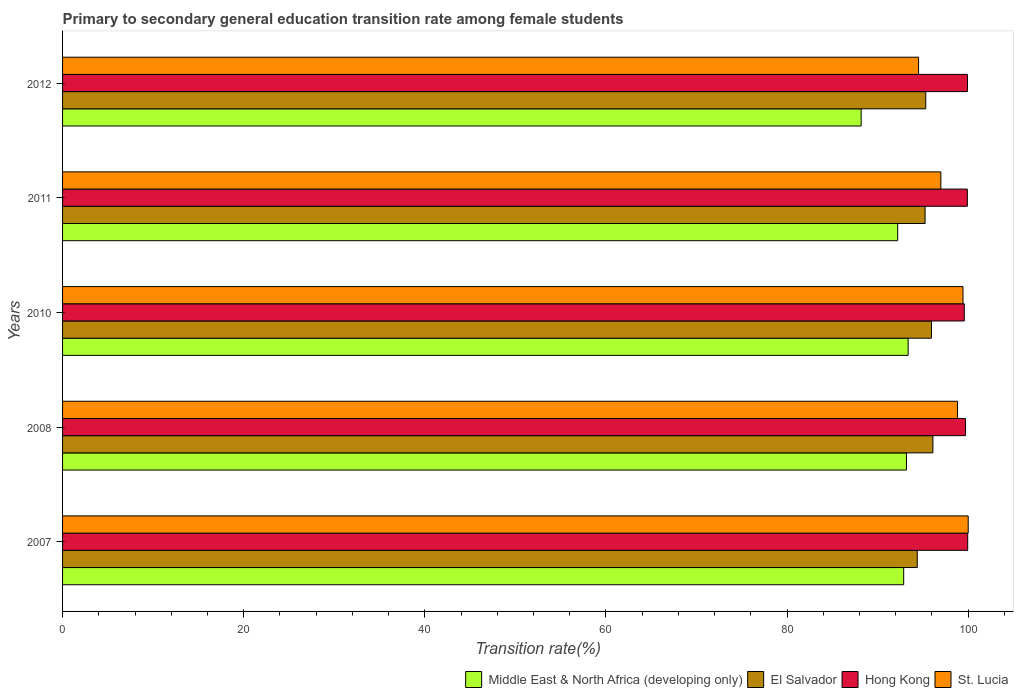How many groups of bars are there?
Your answer should be compact. 5. How many bars are there on the 4th tick from the bottom?
Offer a terse response. 4. What is the transition rate in St. Lucia in 2011?
Ensure brevity in your answer.  96.98. Across all years, what is the maximum transition rate in Hong Kong?
Provide a short and direct response. 99.94. Across all years, what is the minimum transition rate in St. Lucia?
Your answer should be compact. 94.52. What is the total transition rate in Hong Kong in the graph?
Provide a short and direct response. 499.03. What is the difference between the transition rate in St. Lucia in 2008 and that in 2010?
Your answer should be very brief. -0.6. What is the difference between the transition rate in Hong Kong in 2010 and the transition rate in Middle East & North Africa (developing only) in 2011?
Ensure brevity in your answer.  7.35. What is the average transition rate in Middle East & North Africa (developing only) per year?
Provide a short and direct response. 91.96. In the year 2012, what is the difference between the transition rate in St. Lucia and transition rate in El Salvador?
Give a very brief answer. -0.79. What is the ratio of the transition rate in Hong Kong in 2008 to that in 2012?
Your answer should be very brief. 1. Is the transition rate in Middle East & North Africa (developing only) in 2008 less than that in 2010?
Offer a very short reply. Yes. Is the difference between the transition rate in St. Lucia in 2007 and 2008 greater than the difference between the transition rate in El Salvador in 2007 and 2008?
Your response must be concise. Yes. What is the difference between the highest and the second highest transition rate in Hong Kong?
Provide a succinct answer. 0.03. What is the difference between the highest and the lowest transition rate in Middle East & North Africa (developing only)?
Offer a very short reply. 5.19. In how many years, is the transition rate in El Salvador greater than the average transition rate in El Salvador taken over all years?
Make the answer very short. 2. Is the sum of the transition rate in Middle East & North Africa (developing only) in 2010 and 2012 greater than the maximum transition rate in El Salvador across all years?
Offer a terse response. Yes. Is it the case that in every year, the sum of the transition rate in El Salvador and transition rate in St. Lucia is greater than the sum of transition rate in Middle East & North Africa (developing only) and transition rate in Hong Kong?
Your answer should be compact. No. What does the 3rd bar from the top in 2012 represents?
Offer a terse response. El Salvador. What does the 2nd bar from the bottom in 2011 represents?
Provide a short and direct response. El Salvador. Are all the bars in the graph horizontal?
Your answer should be compact. Yes. What is the difference between two consecutive major ticks on the X-axis?
Your answer should be compact. 20. Are the values on the major ticks of X-axis written in scientific E-notation?
Provide a succinct answer. No. Does the graph contain any zero values?
Offer a terse response. No. How many legend labels are there?
Make the answer very short. 4. How are the legend labels stacked?
Your answer should be compact. Horizontal. What is the title of the graph?
Your response must be concise. Primary to secondary general education transition rate among female students. Does "Nepal" appear as one of the legend labels in the graph?
Your answer should be compact. No. What is the label or title of the X-axis?
Your answer should be very brief. Transition rate(%). What is the Transition rate(%) of Middle East & North Africa (developing only) in 2007?
Provide a succinct answer. 92.88. What is the Transition rate(%) of El Salvador in 2007?
Make the answer very short. 94.37. What is the Transition rate(%) of Hong Kong in 2007?
Offer a terse response. 99.94. What is the Transition rate(%) of St. Lucia in 2007?
Keep it short and to the point. 100. What is the Transition rate(%) of Middle East & North Africa (developing only) in 2008?
Give a very brief answer. 93.18. What is the Transition rate(%) of El Salvador in 2008?
Your answer should be very brief. 96.1. What is the Transition rate(%) in Hong Kong in 2008?
Your answer should be very brief. 99.7. What is the Transition rate(%) in St. Lucia in 2008?
Ensure brevity in your answer.  98.82. What is the Transition rate(%) in Middle East & North Africa (developing only) in 2010?
Provide a short and direct response. 93.37. What is the Transition rate(%) in El Salvador in 2010?
Offer a very short reply. 95.94. What is the Transition rate(%) in Hong Kong in 2010?
Keep it short and to the point. 99.57. What is the Transition rate(%) of St. Lucia in 2010?
Ensure brevity in your answer.  99.42. What is the Transition rate(%) in Middle East & North Africa (developing only) in 2011?
Provide a short and direct response. 92.22. What is the Transition rate(%) of El Salvador in 2011?
Give a very brief answer. 95.24. What is the Transition rate(%) of Hong Kong in 2011?
Keep it short and to the point. 99.9. What is the Transition rate(%) in St. Lucia in 2011?
Your answer should be compact. 96.98. What is the Transition rate(%) in Middle East & North Africa (developing only) in 2012?
Ensure brevity in your answer.  88.18. What is the Transition rate(%) in El Salvador in 2012?
Provide a succinct answer. 95.31. What is the Transition rate(%) in Hong Kong in 2012?
Your response must be concise. 99.92. What is the Transition rate(%) of St. Lucia in 2012?
Your answer should be very brief. 94.52. Across all years, what is the maximum Transition rate(%) of Middle East & North Africa (developing only)?
Offer a very short reply. 93.37. Across all years, what is the maximum Transition rate(%) in El Salvador?
Provide a short and direct response. 96.1. Across all years, what is the maximum Transition rate(%) of Hong Kong?
Your answer should be very brief. 99.94. Across all years, what is the maximum Transition rate(%) of St. Lucia?
Provide a succinct answer. 100. Across all years, what is the minimum Transition rate(%) of Middle East & North Africa (developing only)?
Provide a short and direct response. 88.18. Across all years, what is the minimum Transition rate(%) in El Salvador?
Give a very brief answer. 94.37. Across all years, what is the minimum Transition rate(%) in Hong Kong?
Your response must be concise. 99.57. Across all years, what is the minimum Transition rate(%) in St. Lucia?
Offer a terse response. 94.52. What is the total Transition rate(%) of Middle East & North Africa (developing only) in the graph?
Your response must be concise. 459.82. What is the total Transition rate(%) in El Salvador in the graph?
Offer a terse response. 476.97. What is the total Transition rate(%) in Hong Kong in the graph?
Provide a short and direct response. 499.03. What is the total Transition rate(%) of St. Lucia in the graph?
Your answer should be very brief. 489.75. What is the difference between the Transition rate(%) in Middle East & North Africa (developing only) in 2007 and that in 2008?
Your response must be concise. -0.31. What is the difference between the Transition rate(%) of El Salvador in 2007 and that in 2008?
Offer a very short reply. -1.73. What is the difference between the Transition rate(%) in Hong Kong in 2007 and that in 2008?
Ensure brevity in your answer.  0.24. What is the difference between the Transition rate(%) of St. Lucia in 2007 and that in 2008?
Keep it short and to the point. 1.18. What is the difference between the Transition rate(%) of Middle East & North Africa (developing only) in 2007 and that in 2010?
Provide a short and direct response. -0.49. What is the difference between the Transition rate(%) of El Salvador in 2007 and that in 2010?
Offer a very short reply. -1.57. What is the difference between the Transition rate(%) in Hong Kong in 2007 and that in 2010?
Your answer should be compact. 0.38. What is the difference between the Transition rate(%) of St. Lucia in 2007 and that in 2010?
Offer a terse response. 0.58. What is the difference between the Transition rate(%) of Middle East & North Africa (developing only) in 2007 and that in 2011?
Offer a very short reply. 0.66. What is the difference between the Transition rate(%) of El Salvador in 2007 and that in 2011?
Your answer should be very brief. -0.87. What is the difference between the Transition rate(%) in Hong Kong in 2007 and that in 2011?
Provide a succinct answer. 0.04. What is the difference between the Transition rate(%) in St. Lucia in 2007 and that in 2011?
Provide a succinct answer. 3.02. What is the difference between the Transition rate(%) in Middle East & North Africa (developing only) in 2007 and that in 2012?
Make the answer very short. 4.7. What is the difference between the Transition rate(%) in El Salvador in 2007 and that in 2012?
Your answer should be compact. -0.94. What is the difference between the Transition rate(%) in Hong Kong in 2007 and that in 2012?
Provide a short and direct response. 0.03. What is the difference between the Transition rate(%) of St. Lucia in 2007 and that in 2012?
Ensure brevity in your answer.  5.48. What is the difference between the Transition rate(%) in Middle East & North Africa (developing only) in 2008 and that in 2010?
Give a very brief answer. -0.18. What is the difference between the Transition rate(%) in El Salvador in 2008 and that in 2010?
Make the answer very short. 0.16. What is the difference between the Transition rate(%) in Hong Kong in 2008 and that in 2010?
Your answer should be compact. 0.14. What is the difference between the Transition rate(%) in St. Lucia in 2008 and that in 2010?
Your answer should be very brief. -0.6. What is the difference between the Transition rate(%) of Middle East & North Africa (developing only) in 2008 and that in 2011?
Offer a very short reply. 0.96. What is the difference between the Transition rate(%) in El Salvador in 2008 and that in 2011?
Make the answer very short. 0.86. What is the difference between the Transition rate(%) of Hong Kong in 2008 and that in 2011?
Offer a very short reply. -0.2. What is the difference between the Transition rate(%) in St. Lucia in 2008 and that in 2011?
Give a very brief answer. 1.84. What is the difference between the Transition rate(%) of Middle East & North Africa (developing only) in 2008 and that in 2012?
Give a very brief answer. 5. What is the difference between the Transition rate(%) of El Salvador in 2008 and that in 2012?
Provide a succinct answer. 0.79. What is the difference between the Transition rate(%) of Hong Kong in 2008 and that in 2012?
Make the answer very short. -0.22. What is the difference between the Transition rate(%) of St. Lucia in 2008 and that in 2012?
Give a very brief answer. 4.3. What is the difference between the Transition rate(%) of Middle East & North Africa (developing only) in 2010 and that in 2011?
Your answer should be compact. 1.15. What is the difference between the Transition rate(%) of El Salvador in 2010 and that in 2011?
Make the answer very short. 0.71. What is the difference between the Transition rate(%) in Hong Kong in 2010 and that in 2011?
Offer a terse response. -0.34. What is the difference between the Transition rate(%) of St. Lucia in 2010 and that in 2011?
Offer a terse response. 2.44. What is the difference between the Transition rate(%) of Middle East & North Africa (developing only) in 2010 and that in 2012?
Make the answer very short. 5.19. What is the difference between the Transition rate(%) in El Salvador in 2010 and that in 2012?
Offer a very short reply. 0.63. What is the difference between the Transition rate(%) in Hong Kong in 2010 and that in 2012?
Give a very brief answer. -0.35. What is the difference between the Transition rate(%) in St. Lucia in 2010 and that in 2012?
Provide a short and direct response. 4.91. What is the difference between the Transition rate(%) in Middle East & North Africa (developing only) in 2011 and that in 2012?
Offer a very short reply. 4.04. What is the difference between the Transition rate(%) of El Salvador in 2011 and that in 2012?
Keep it short and to the point. -0.07. What is the difference between the Transition rate(%) of Hong Kong in 2011 and that in 2012?
Give a very brief answer. -0.01. What is the difference between the Transition rate(%) in St. Lucia in 2011 and that in 2012?
Provide a short and direct response. 2.46. What is the difference between the Transition rate(%) of Middle East & North Africa (developing only) in 2007 and the Transition rate(%) of El Salvador in 2008?
Ensure brevity in your answer.  -3.23. What is the difference between the Transition rate(%) of Middle East & North Africa (developing only) in 2007 and the Transition rate(%) of Hong Kong in 2008?
Your answer should be very brief. -6.83. What is the difference between the Transition rate(%) in Middle East & North Africa (developing only) in 2007 and the Transition rate(%) in St. Lucia in 2008?
Keep it short and to the point. -5.95. What is the difference between the Transition rate(%) in El Salvador in 2007 and the Transition rate(%) in Hong Kong in 2008?
Ensure brevity in your answer.  -5.33. What is the difference between the Transition rate(%) in El Salvador in 2007 and the Transition rate(%) in St. Lucia in 2008?
Make the answer very short. -4.45. What is the difference between the Transition rate(%) of Hong Kong in 2007 and the Transition rate(%) of St. Lucia in 2008?
Your answer should be compact. 1.12. What is the difference between the Transition rate(%) of Middle East & North Africa (developing only) in 2007 and the Transition rate(%) of El Salvador in 2010?
Offer a very short reply. -3.07. What is the difference between the Transition rate(%) of Middle East & North Africa (developing only) in 2007 and the Transition rate(%) of Hong Kong in 2010?
Provide a short and direct response. -6.69. What is the difference between the Transition rate(%) of Middle East & North Africa (developing only) in 2007 and the Transition rate(%) of St. Lucia in 2010?
Offer a very short reply. -6.55. What is the difference between the Transition rate(%) in El Salvador in 2007 and the Transition rate(%) in Hong Kong in 2010?
Make the answer very short. -5.19. What is the difference between the Transition rate(%) of El Salvador in 2007 and the Transition rate(%) of St. Lucia in 2010?
Offer a very short reply. -5.05. What is the difference between the Transition rate(%) of Hong Kong in 2007 and the Transition rate(%) of St. Lucia in 2010?
Provide a succinct answer. 0.52. What is the difference between the Transition rate(%) in Middle East & North Africa (developing only) in 2007 and the Transition rate(%) in El Salvador in 2011?
Offer a very short reply. -2.36. What is the difference between the Transition rate(%) of Middle East & North Africa (developing only) in 2007 and the Transition rate(%) of Hong Kong in 2011?
Offer a very short reply. -7.03. What is the difference between the Transition rate(%) in Middle East & North Africa (developing only) in 2007 and the Transition rate(%) in St. Lucia in 2011?
Keep it short and to the point. -4.11. What is the difference between the Transition rate(%) in El Salvador in 2007 and the Transition rate(%) in Hong Kong in 2011?
Offer a very short reply. -5.53. What is the difference between the Transition rate(%) in El Salvador in 2007 and the Transition rate(%) in St. Lucia in 2011?
Make the answer very short. -2.61. What is the difference between the Transition rate(%) of Hong Kong in 2007 and the Transition rate(%) of St. Lucia in 2011?
Ensure brevity in your answer.  2.96. What is the difference between the Transition rate(%) of Middle East & North Africa (developing only) in 2007 and the Transition rate(%) of El Salvador in 2012?
Offer a terse response. -2.43. What is the difference between the Transition rate(%) of Middle East & North Africa (developing only) in 2007 and the Transition rate(%) of Hong Kong in 2012?
Provide a short and direct response. -7.04. What is the difference between the Transition rate(%) of Middle East & North Africa (developing only) in 2007 and the Transition rate(%) of St. Lucia in 2012?
Keep it short and to the point. -1.64. What is the difference between the Transition rate(%) in El Salvador in 2007 and the Transition rate(%) in Hong Kong in 2012?
Your answer should be compact. -5.55. What is the difference between the Transition rate(%) in El Salvador in 2007 and the Transition rate(%) in St. Lucia in 2012?
Give a very brief answer. -0.15. What is the difference between the Transition rate(%) of Hong Kong in 2007 and the Transition rate(%) of St. Lucia in 2012?
Your answer should be compact. 5.43. What is the difference between the Transition rate(%) in Middle East & North Africa (developing only) in 2008 and the Transition rate(%) in El Salvador in 2010?
Keep it short and to the point. -2.76. What is the difference between the Transition rate(%) of Middle East & North Africa (developing only) in 2008 and the Transition rate(%) of Hong Kong in 2010?
Your answer should be compact. -6.38. What is the difference between the Transition rate(%) in Middle East & North Africa (developing only) in 2008 and the Transition rate(%) in St. Lucia in 2010?
Make the answer very short. -6.24. What is the difference between the Transition rate(%) of El Salvador in 2008 and the Transition rate(%) of Hong Kong in 2010?
Make the answer very short. -3.46. What is the difference between the Transition rate(%) in El Salvador in 2008 and the Transition rate(%) in St. Lucia in 2010?
Keep it short and to the point. -3.32. What is the difference between the Transition rate(%) of Hong Kong in 2008 and the Transition rate(%) of St. Lucia in 2010?
Provide a succinct answer. 0.28. What is the difference between the Transition rate(%) in Middle East & North Africa (developing only) in 2008 and the Transition rate(%) in El Salvador in 2011?
Provide a succinct answer. -2.06. What is the difference between the Transition rate(%) in Middle East & North Africa (developing only) in 2008 and the Transition rate(%) in Hong Kong in 2011?
Provide a short and direct response. -6.72. What is the difference between the Transition rate(%) in Middle East & North Africa (developing only) in 2008 and the Transition rate(%) in St. Lucia in 2011?
Provide a succinct answer. -3.8. What is the difference between the Transition rate(%) of El Salvador in 2008 and the Transition rate(%) of Hong Kong in 2011?
Your response must be concise. -3.8. What is the difference between the Transition rate(%) of El Salvador in 2008 and the Transition rate(%) of St. Lucia in 2011?
Your answer should be very brief. -0.88. What is the difference between the Transition rate(%) in Hong Kong in 2008 and the Transition rate(%) in St. Lucia in 2011?
Make the answer very short. 2.72. What is the difference between the Transition rate(%) in Middle East & North Africa (developing only) in 2008 and the Transition rate(%) in El Salvador in 2012?
Your answer should be compact. -2.13. What is the difference between the Transition rate(%) in Middle East & North Africa (developing only) in 2008 and the Transition rate(%) in Hong Kong in 2012?
Provide a short and direct response. -6.74. What is the difference between the Transition rate(%) of Middle East & North Africa (developing only) in 2008 and the Transition rate(%) of St. Lucia in 2012?
Offer a very short reply. -1.34. What is the difference between the Transition rate(%) in El Salvador in 2008 and the Transition rate(%) in Hong Kong in 2012?
Provide a succinct answer. -3.82. What is the difference between the Transition rate(%) of El Salvador in 2008 and the Transition rate(%) of St. Lucia in 2012?
Provide a short and direct response. 1.58. What is the difference between the Transition rate(%) in Hong Kong in 2008 and the Transition rate(%) in St. Lucia in 2012?
Offer a terse response. 5.18. What is the difference between the Transition rate(%) in Middle East & North Africa (developing only) in 2010 and the Transition rate(%) in El Salvador in 2011?
Your answer should be compact. -1.87. What is the difference between the Transition rate(%) of Middle East & North Africa (developing only) in 2010 and the Transition rate(%) of Hong Kong in 2011?
Provide a short and direct response. -6.54. What is the difference between the Transition rate(%) in Middle East & North Africa (developing only) in 2010 and the Transition rate(%) in St. Lucia in 2011?
Offer a very short reply. -3.62. What is the difference between the Transition rate(%) in El Salvador in 2010 and the Transition rate(%) in Hong Kong in 2011?
Offer a terse response. -3.96. What is the difference between the Transition rate(%) of El Salvador in 2010 and the Transition rate(%) of St. Lucia in 2011?
Offer a very short reply. -1.04. What is the difference between the Transition rate(%) in Hong Kong in 2010 and the Transition rate(%) in St. Lucia in 2011?
Your answer should be compact. 2.58. What is the difference between the Transition rate(%) of Middle East & North Africa (developing only) in 2010 and the Transition rate(%) of El Salvador in 2012?
Your response must be concise. -1.94. What is the difference between the Transition rate(%) in Middle East & North Africa (developing only) in 2010 and the Transition rate(%) in Hong Kong in 2012?
Your response must be concise. -6.55. What is the difference between the Transition rate(%) of Middle East & North Africa (developing only) in 2010 and the Transition rate(%) of St. Lucia in 2012?
Your answer should be compact. -1.15. What is the difference between the Transition rate(%) in El Salvador in 2010 and the Transition rate(%) in Hong Kong in 2012?
Offer a very short reply. -3.97. What is the difference between the Transition rate(%) in El Salvador in 2010 and the Transition rate(%) in St. Lucia in 2012?
Give a very brief answer. 1.43. What is the difference between the Transition rate(%) in Hong Kong in 2010 and the Transition rate(%) in St. Lucia in 2012?
Make the answer very short. 5.05. What is the difference between the Transition rate(%) in Middle East & North Africa (developing only) in 2011 and the Transition rate(%) in El Salvador in 2012?
Ensure brevity in your answer.  -3.09. What is the difference between the Transition rate(%) in Middle East & North Africa (developing only) in 2011 and the Transition rate(%) in Hong Kong in 2012?
Ensure brevity in your answer.  -7.7. What is the difference between the Transition rate(%) of Middle East & North Africa (developing only) in 2011 and the Transition rate(%) of St. Lucia in 2012?
Offer a very short reply. -2.3. What is the difference between the Transition rate(%) in El Salvador in 2011 and the Transition rate(%) in Hong Kong in 2012?
Your response must be concise. -4.68. What is the difference between the Transition rate(%) in El Salvador in 2011 and the Transition rate(%) in St. Lucia in 2012?
Your answer should be very brief. 0.72. What is the difference between the Transition rate(%) in Hong Kong in 2011 and the Transition rate(%) in St. Lucia in 2012?
Your answer should be very brief. 5.39. What is the average Transition rate(%) of Middle East & North Africa (developing only) per year?
Keep it short and to the point. 91.96. What is the average Transition rate(%) in El Salvador per year?
Your answer should be very brief. 95.39. What is the average Transition rate(%) of Hong Kong per year?
Your answer should be very brief. 99.81. What is the average Transition rate(%) in St. Lucia per year?
Keep it short and to the point. 97.95. In the year 2007, what is the difference between the Transition rate(%) in Middle East & North Africa (developing only) and Transition rate(%) in El Salvador?
Give a very brief answer. -1.5. In the year 2007, what is the difference between the Transition rate(%) of Middle East & North Africa (developing only) and Transition rate(%) of Hong Kong?
Give a very brief answer. -7.07. In the year 2007, what is the difference between the Transition rate(%) in Middle East & North Africa (developing only) and Transition rate(%) in St. Lucia?
Your answer should be compact. -7.12. In the year 2007, what is the difference between the Transition rate(%) of El Salvador and Transition rate(%) of Hong Kong?
Provide a succinct answer. -5.57. In the year 2007, what is the difference between the Transition rate(%) in El Salvador and Transition rate(%) in St. Lucia?
Offer a terse response. -5.63. In the year 2007, what is the difference between the Transition rate(%) in Hong Kong and Transition rate(%) in St. Lucia?
Offer a terse response. -0.06. In the year 2008, what is the difference between the Transition rate(%) in Middle East & North Africa (developing only) and Transition rate(%) in El Salvador?
Your answer should be very brief. -2.92. In the year 2008, what is the difference between the Transition rate(%) of Middle East & North Africa (developing only) and Transition rate(%) of Hong Kong?
Provide a short and direct response. -6.52. In the year 2008, what is the difference between the Transition rate(%) in Middle East & North Africa (developing only) and Transition rate(%) in St. Lucia?
Your response must be concise. -5.64. In the year 2008, what is the difference between the Transition rate(%) of El Salvador and Transition rate(%) of Hong Kong?
Provide a short and direct response. -3.6. In the year 2008, what is the difference between the Transition rate(%) of El Salvador and Transition rate(%) of St. Lucia?
Your answer should be very brief. -2.72. In the year 2008, what is the difference between the Transition rate(%) of Hong Kong and Transition rate(%) of St. Lucia?
Offer a very short reply. 0.88. In the year 2010, what is the difference between the Transition rate(%) of Middle East & North Africa (developing only) and Transition rate(%) of El Salvador?
Your answer should be very brief. -2.58. In the year 2010, what is the difference between the Transition rate(%) in Middle East & North Africa (developing only) and Transition rate(%) in Hong Kong?
Your answer should be very brief. -6.2. In the year 2010, what is the difference between the Transition rate(%) of Middle East & North Africa (developing only) and Transition rate(%) of St. Lucia?
Ensure brevity in your answer.  -6.06. In the year 2010, what is the difference between the Transition rate(%) of El Salvador and Transition rate(%) of Hong Kong?
Your answer should be very brief. -3.62. In the year 2010, what is the difference between the Transition rate(%) of El Salvador and Transition rate(%) of St. Lucia?
Your answer should be compact. -3.48. In the year 2010, what is the difference between the Transition rate(%) in Hong Kong and Transition rate(%) in St. Lucia?
Provide a succinct answer. 0.14. In the year 2011, what is the difference between the Transition rate(%) of Middle East & North Africa (developing only) and Transition rate(%) of El Salvador?
Your response must be concise. -3.02. In the year 2011, what is the difference between the Transition rate(%) of Middle East & North Africa (developing only) and Transition rate(%) of Hong Kong?
Your answer should be compact. -7.69. In the year 2011, what is the difference between the Transition rate(%) in Middle East & North Africa (developing only) and Transition rate(%) in St. Lucia?
Keep it short and to the point. -4.77. In the year 2011, what is the difference between the Transition rate(%) in El Salvador and Transition rate(%) in Hong Kong?
Provide a short and direct response. -4.67. In the year 2011, what is the difference between the Transition rate(%) of El Salvador and Transition rate(%) of St. Lucia?
Your answer should be compact. -1.74. In the year 2011, what is the difference between the Transition rate(%) of Hong Kong and Transition rate(%) of St. Lucia?
Offer a very short reply. 2.92. In the year 2012, what is the difference between the Transition rate(%) of Middle East & North Africa (developing only) and Transition rate(%) of El Salvador?
Your answer should be compact. -7.13. In the year 2012, what is the difference between the Transition rate(%) in Middle East & North Africa (developing only) and Transition rate(%) in Hong Kong?
Your answer should be very brief. -11.74. In the year 2012, what is the difference between the Transition rate(%) of Middle East & North Africa (developing only) and Transition rate(%) of St. Lucia?
Your response must be concise. -6.34. In the year 2012, what is the difference between the Transition rate(%) in El Salvador and Transition rate(%) in Hong Kong?
Offer a very short reply. -4.61. In the year 2012, what is the difference between the Transition rate(%) of El Salvador and Transition rate(%) of St. Lucia?
Your answer should be compact. 0.79. In the year 2012, what is the difference between the Transition rate(%) in Hong Kong and Transition rate(%) in St. Lucia?
Provide a succinct answer. 5.4. What is the ratio of the Transition rate(%) in Middle East & North Africa (developing only) in 2007 to that in 2008?
Make the answer very short. 1. What is the ratio of the Transition rate(%) in Hong Kong in 2007 to that in 2008?
Your response must be concise. 1. What is the ratio of the Transition rate(%) in St. Lucia in 2007 to that in 2008?
Ensure brevity in your answer.  1.01. What is the ratio of the Transition rate(%) of Middle East & North Africa (developing only) in 2007 to that in 2010?
Provide a short and direct response. 0.99. What is the ratio of the Transition rate(%) of El Salvador in 2007 to that in 2010?
Your answer should be compact. 0.98. What is the ratio of the Transition rate(%) of Hong Kong in 2007 to that in 2010?
Provide a short and direct response. 1. What is the ratio of the Transition rate(%) of Middle East & North Africa (developing only) in 2007 to that in 2011?
Provide a succinct answer. 1.01. What is the ratio of the Transition rate(%) in El Salvador in 2007 to that in 2011?
Provide a succinct answer. 0.99. What is the ratio of the Transition rate(%) of St. Lucia in 2007 to that in 2011?
Provide a succinct answer. 1.03. What is the ratio of the Transition rate(%) in Middle East & North Africa (developing only) in 2007 to that in 2012?
Ensure brevity in your answer.  1.05. What is the ratio of the Transition rate(%) of El Salvador in 2007 to that in 2012?
Ensure brevity in your answer.  0.99. What is the ratio of the Transition rate(%) in Hong Kong in 2007 to that in 2012?
Make the answer very short. 1. What is the ratio of the Transition rate(%) in St. Lucia in 2007 to that in 2012?
Offer a terse response. 1.06. What is the ratio of the Transition rate(%) of Middle East & North Africa (developing only) in 2008 to that in 2010?
Offer a terse response. 1. What is the ratio of the Transition rate(%) of Hong Kong in 2008 to that in 2010?
Your response must be concise. 1. What is the ratio of the Transition rate(%) of St. Lucia in 2008 to that in 2010?
Provide a short and direct response. 0.99. What is the ratio of the Transition rate(%) in Middle East & North Africa (developing only) in 2008 to that in 2011?
Make the answer very short. 1.01. What is the ratio of the Transition rate(%) of Hong Kong in 2008 to that in 2011?
Keep it short and to the point. 1. What is the ratio of the Transition rate(%) of St. Lucia in 2008 to that in 2011?
Your response must be concise. 1.02. What is the ratio of the Transition rate(%) of Middle East & North Africa (developing only) in 2008 to that in 2012?
Your response must be concise. 1.06. What is the ratio of the Transition rate(%) in El Salvador in 2008 to that in 2012?
Keep it short and to the point. 1.01. What is the ratio of the Transition rate(%) of Hong Kong in 2008 to that in 2012?
Offer a very short reply. 1. What is the ratio of the Transition rate(%) of St. Lucia in 2008 to that in 2012?
Your answer should be very brief. 1.05. What is the ratio of the Transition rate(%) of Middle East & North Africa (developing only) in 2010 to that in 2011?
Keep it short and to the point. 1.01. What is the ratio of the Transition rate(%) in El Salvador in 2010 to that in 2011?
Offer a very short reply. 1.01. What is the ratio of the Transition rate(%) of St. Lucia in 2010 to that in 2011?
Give a very brief answer. 1.03. What is the ratio of the Transition rate(%) of Middle East & North Africa (developing only) in 2010 to that in 2012?
Make the answer very short. 1.06. What is the ratio of the Transition rate(%) of Hong Kong in 2010 to that in 2012?
Provide a short and direct response. 1. What is the ratio of the Transition rate(%) of St. Lucia in 2010 to that in 2012?
Your response must be concise. 1.05. What is the ratio of the Transition rate(%) of Middle East & North Africa (developing only) in 2011 to that in 2012?
Offer a very short reply. 1.05. What is the ratio of the Transition rate(%) in St. Lucia in 2011 to that in 2012?
Offer a very short reply. 1.03. What is the difference between the highest and the second highest Transition rate(%) in Middle East & North Africa (developing only)?
Keep it short and to the point. 0.18. What is the difference between the highest and the second highest Transition rate(%) of El Salvador?
Your answer should be compact. 0.16. What is the difference between the highest and the second highest Transition rate(%) in Hong Kong?
Your response must be concise. 0.03. What is the difference between the highest and the second highest Transition rate(%) of St. Lucia?
Provide a short and direct response. 0.58. What is the difference between the highest and the lowest Transition rate(%) in Middle East & North Africa (developing only)?
Offer a very short reply. 5.19. What is the difference between the highest and the lowest Transition rate(%) of El Salvador?
Offer a very short reply. 1.73. What is the difference between the highest and the lowest Transition rate(%) of Hong Kong?
Your response must be concise. 0.38. What is the difference between the highest and the lowest Transition rate(%) of St. Lucia?
Ensure brevity in your answer.  5.48. 